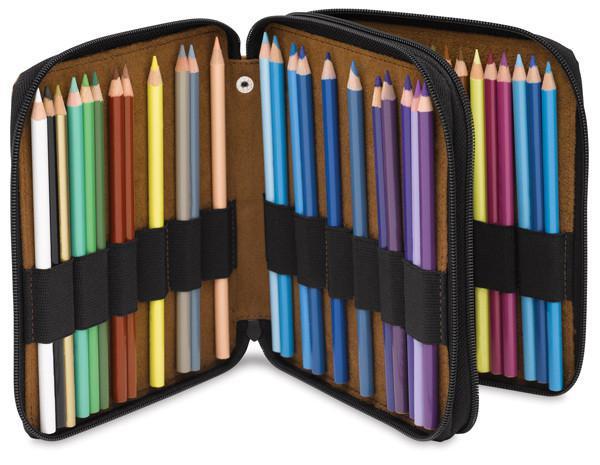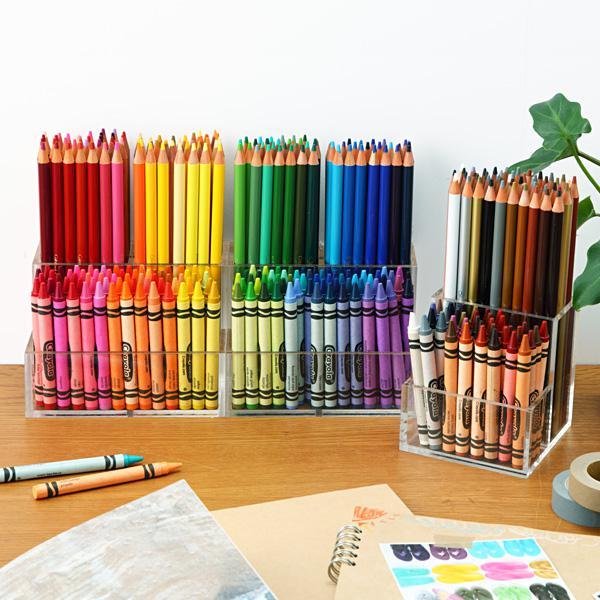The first image is the image on the left, the second image is the image on the right. Considering the images on both sides, is "The pencils in the left image are supported with bands." valid? Answer yes or no. Yes. The first image is the image on the left, the second image is the image on the right. Analyze the images presented: Is the assertion "In at least one picture all of the colored pencils are pointing up." valid? Answer yes or no. Yes. 